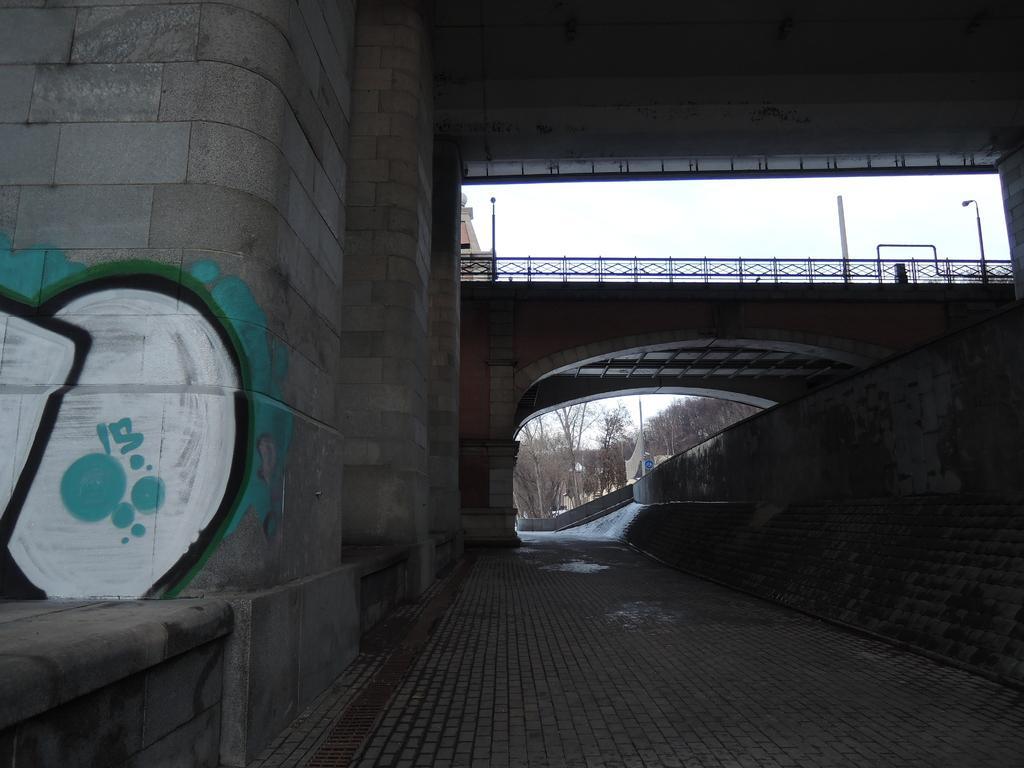Please provide a concise description of this image. At the center of the image there is a bridge, beneath the bridge there is a path of a road. In the background there are trees and sky. 